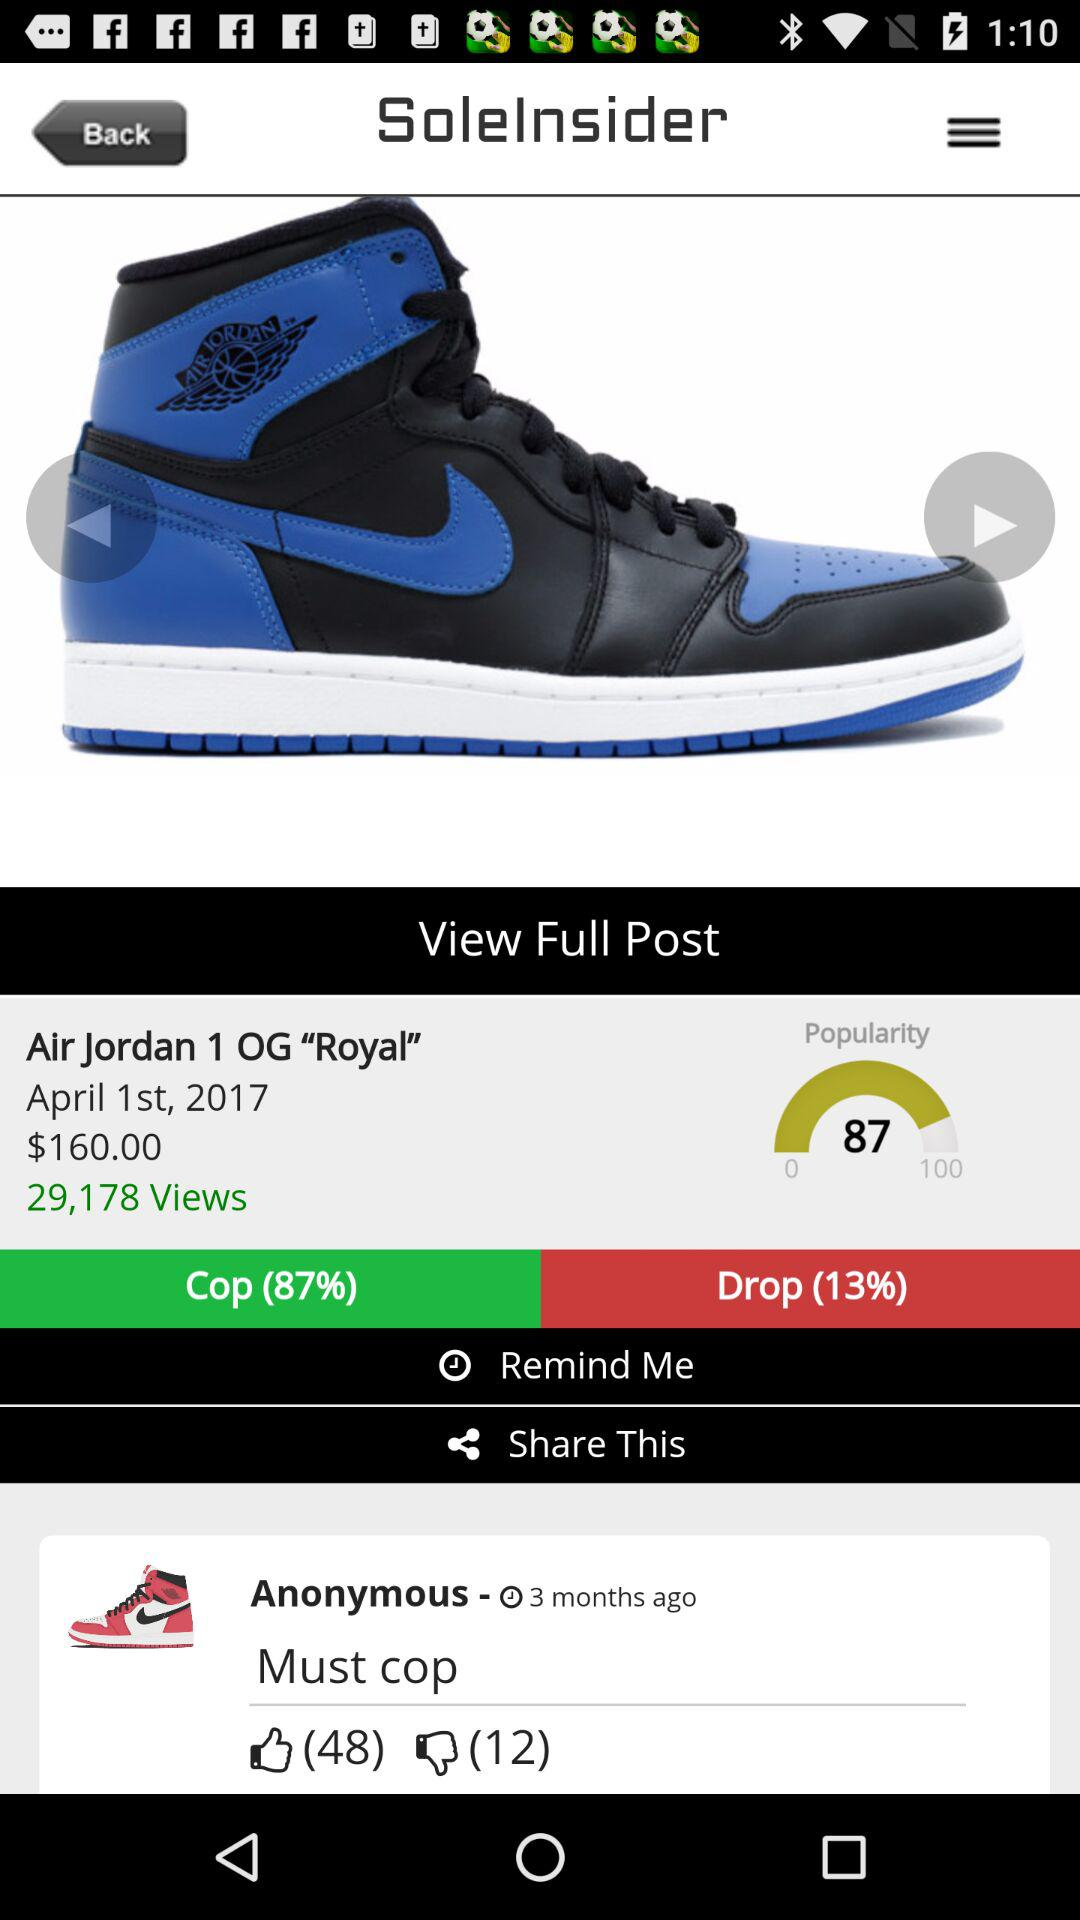How many views are there of "Air Jordan 1 OG "Royal""? There are 29,178 views. 